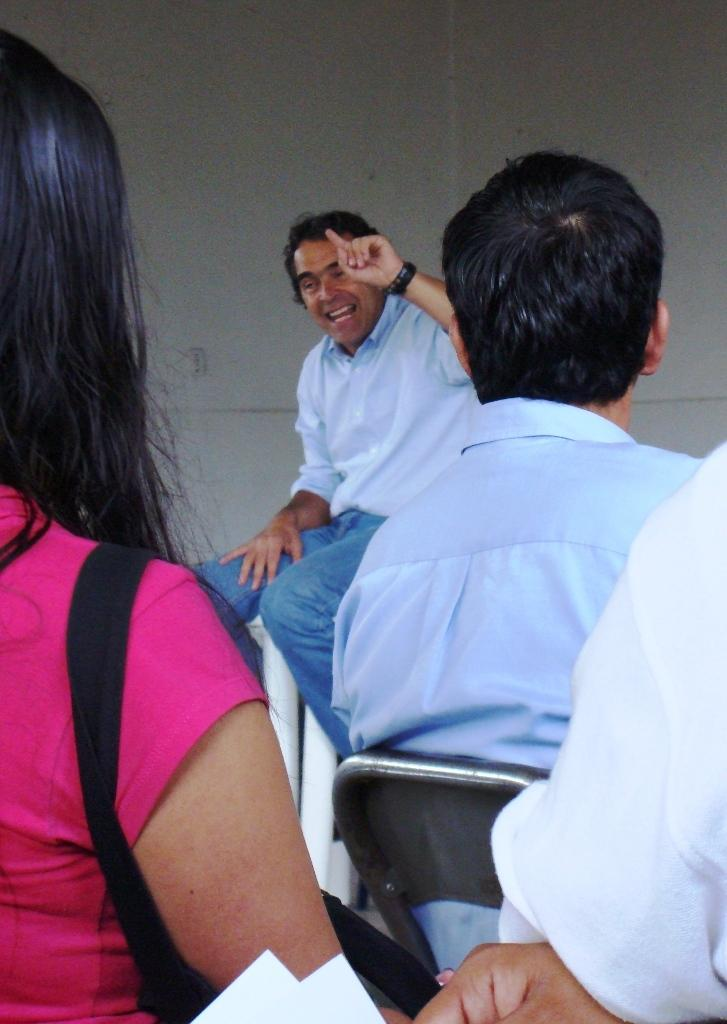What is the gender of the person on the left side of the image? There is a woman on the left side of the image. What is the woman wearing in the image? The woman is wearing a pink t-shirt. What is the man in the middle of the image doing? The man is speaking. What type of clothing is the man wearing in the image? The man is wearing a shirt and trousers. What can be seen at the top of the image? There is a wall visible at the top of the image. What type of pail is the woman holding in the image? There is no pail present in the image. How many hands does the man have in the image? The image does not show the man's hands, so it is not possible to determine the number of hands he has. 